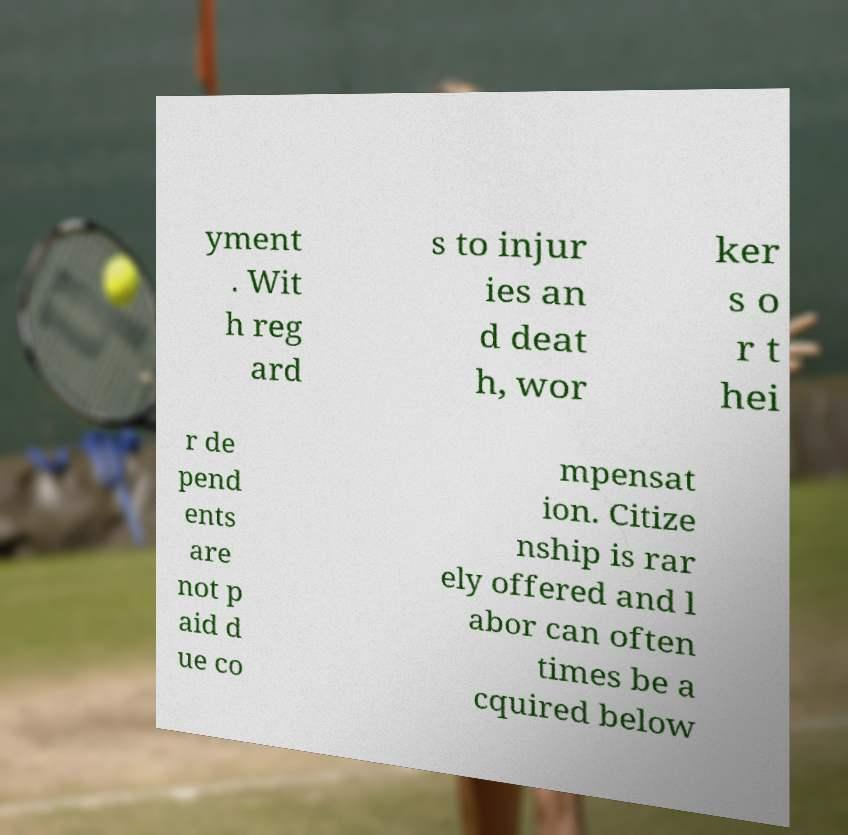There's text embedded in this image that I need extracted. Can you transcribe it verbatim? yment . Wit h reg ard s to injur ies an d deat h, wor ker s o r t hei r de pend ents are not p aid d ue co mpensat ion. Citize nship is rar ely offered and l abor can often times be a cquired below 